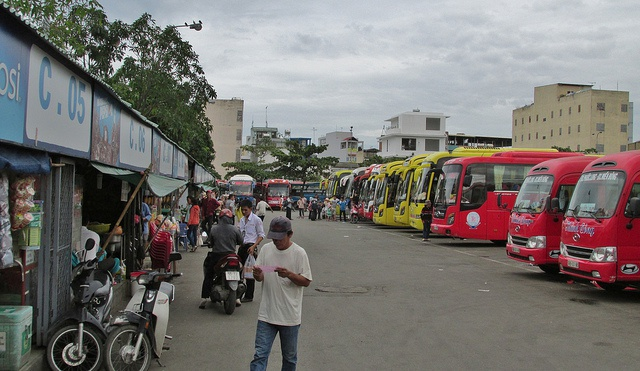Describe the objects in this image and their specific colors. I can see bus in gray, brown, maroon, and black tones, bus in gray, brown, black, and darkgray tones, people in gray, darkgray, and black tones, bus in gray, brown, maroon, and black tones, and motorcycle in gray, black, and darkgray tones in this image. 